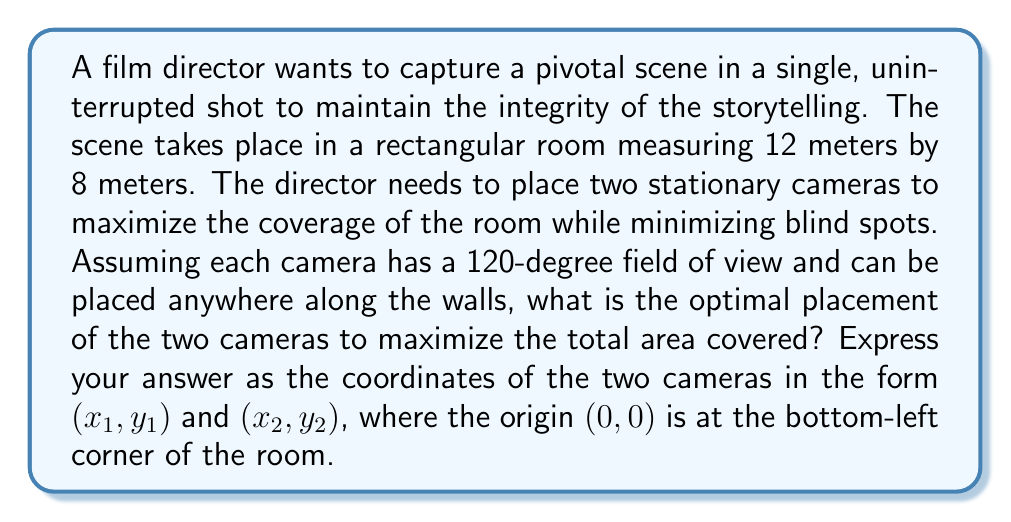Show me your answer to this math problem. To solve this optimization problem, we'll follow these steps:

1) First, we need to understand that the optimal placement will be in opposite corners of the room. This allows the cameras to cover the maximum area without overlap.

2) The best angle for each camera will be 30 degrees from each adjacent wall. This is because the 120-degree field of view will be split equally, with 60 degrees covering each wall adjacent to the corner.

3) Let's consider the first camera in the bottom-left corner (0, 0). We need to calculate how far from the corner it should be placed to achieve the 30-degree angle with both walls.

4) For a right triangle with a 30-degree angle, the ratio of the opposite side to the hypotenuse is 1:2. So, if we call the distance from the corner 'd', we have:

   $$\frac{d}{2d} = \frac{1}{2} = \sin(30°)$$

5) We can calculate 'd' for both the width and height of the room:
   
   For the 12m width: $d_w = 12 \cdot \frac{1}{2} = 6$ meters
   For the 8m height: $d_h = 8 \cdot \frac{1}{2} = 4$ meters

6) Therefore, the coordinates for the first camera are (6, 4).

7) The second camera will be placed in the opposite corner, which is the top-right corner. Its coordinates will be (12 - 6, 8 - 4) = (6, 4).

8) Thus, the optimal camera placements are (6, 4) and (6, 4).

[asy]
unitsize(10mm);
draw((0,0)--(12,0)--(12,8)--(0,8)--cycle);
dot((6,4));
dot((6,4));
draw((6,4)--(12,4), Arrow);
draw((6,4)--(6,8), Arrow);
draw((6,4)--(0,4), Arrow);
draw((6,4)--(6,0), Arrow);
label("(6, 4)", (6,4), SE);
label("(6, 4)", (6,4), NW);
label("12m", (6,0), S);
label("8m", (0,4), W);
[/asy]

This placement ensures that each camera covers half of the room with minimal overlap, maximizing the total area covered.
Answer: The optimal camera placements are (6, 4) and (6, 4). 